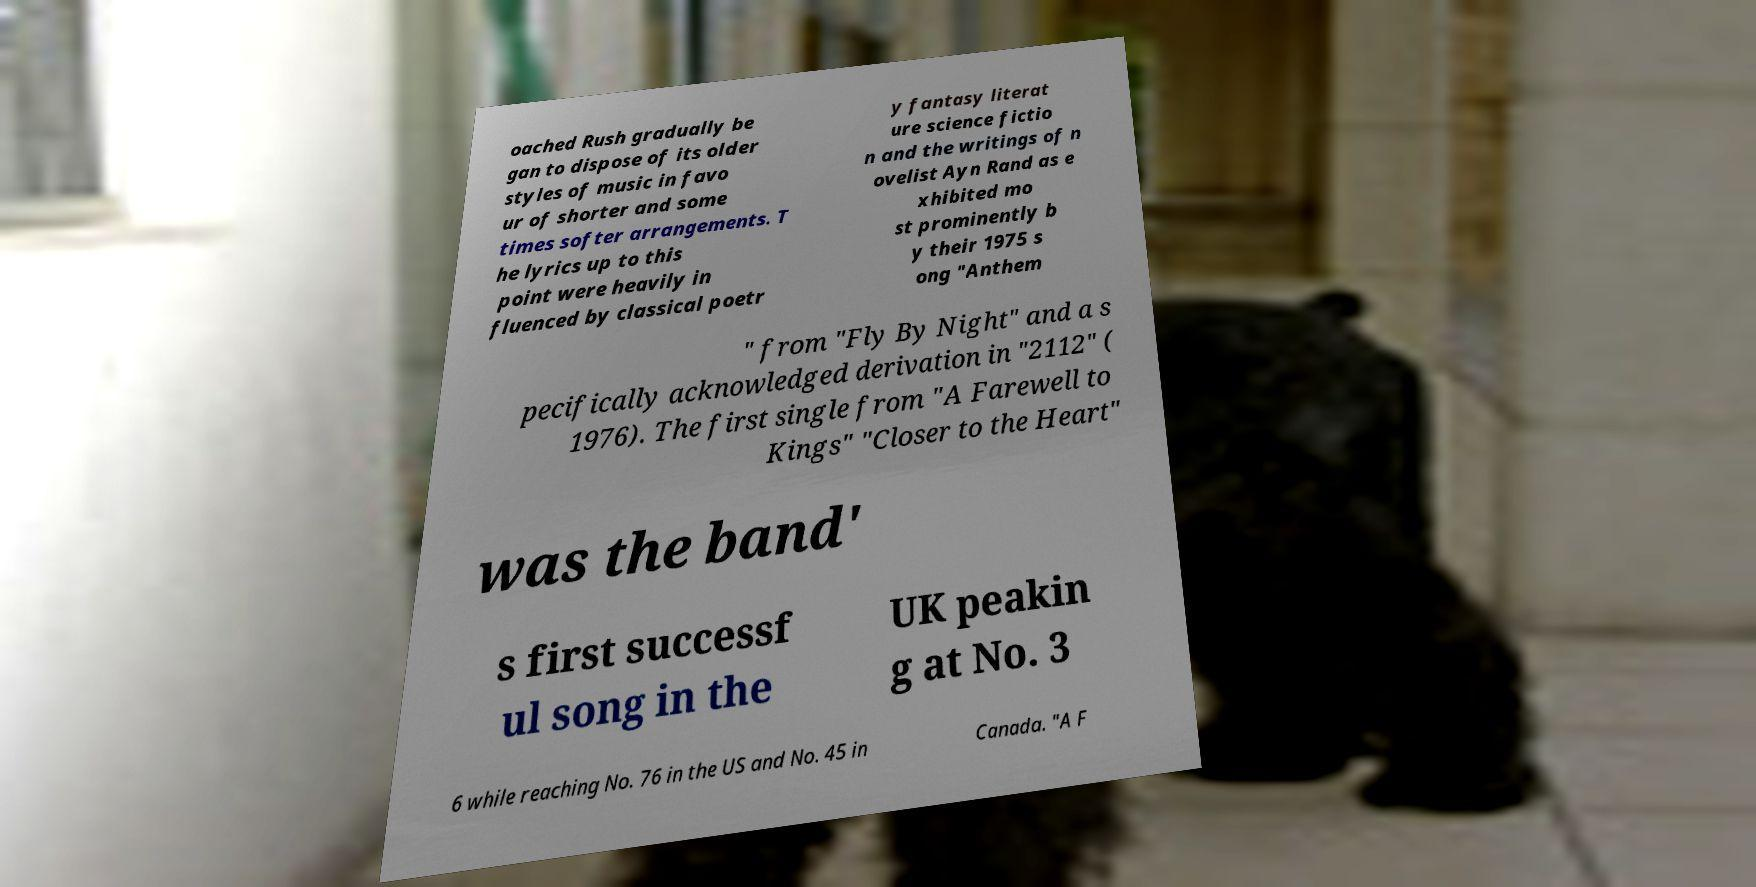Please identify and transcribe the text found in this image. oached Rush gradually be gan to dispose of its older styles of music in favo ur of shorter and some times softer arrangements. T he lyrics up to this point were heavily in fluenced by classical poetr y fantasy literat ure science fictio n and the writings of n ovelist Ayn Rand as e xhibited mo st prominently b y their 1975 s ong "Anthem " from "Fly By Night" and a s pecifically acknowledged derivation in "2112" ( 1976). The first single from "A Farewell to Kings" "Closer to the Heart" was the band' s first successf ul song in the UK peakin g at No. 3 6 while reaching No. 76 in the US and No. 45 in Canada. "A F 